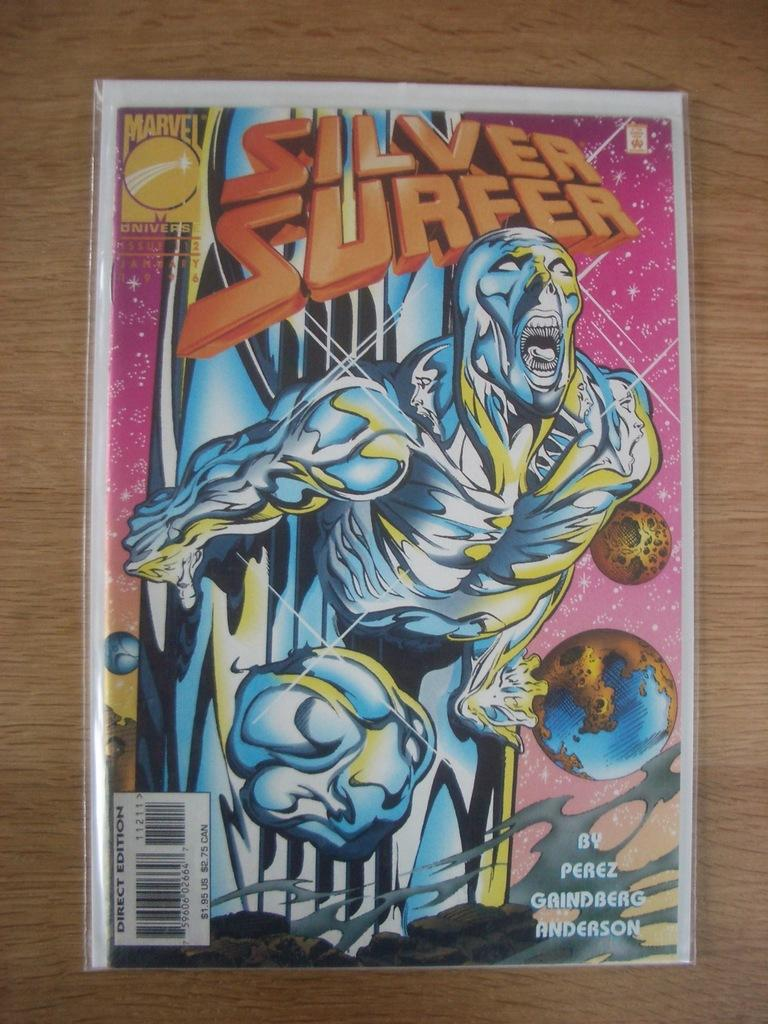What is present on the wall in the image? There is a poster in the image. What is the poster attached to? The poster is attached to a wooden object. What can be read on the poster? The poster contains text. What is depicted on the poster? The poster depicts a human. What additional feature can be found on the poster? The poster includes a barcode. What background is shown on the poster? The poster shows a sky. What other objects are included on the poster? The poster contains various other objects. How does the poster end in the image? The poster does not end in the image; it is a static, two-dimensional object. 